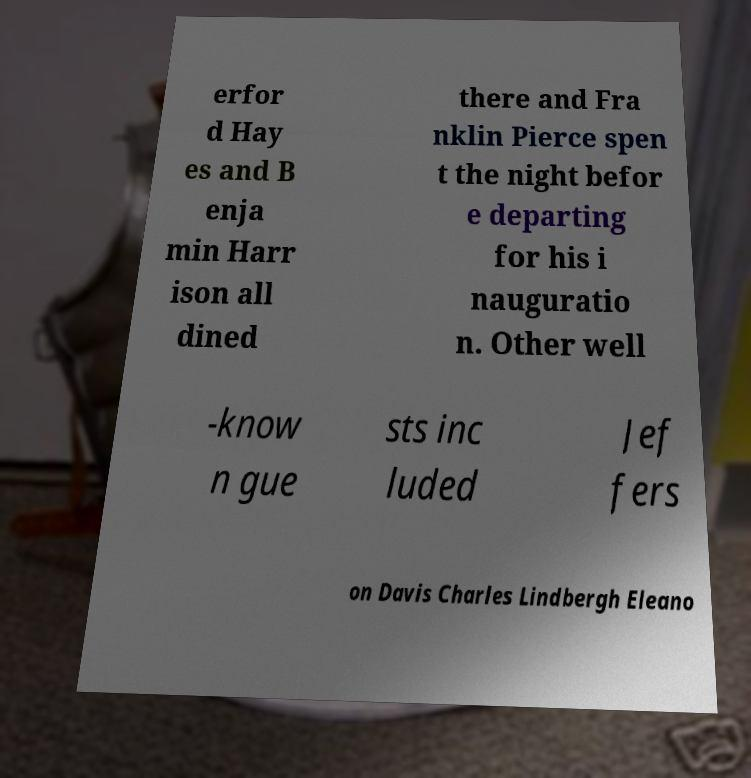For documentation purposes, I need the text within this image transcribed. Could you provide that? erfor d Hay es and B enja min Harr ison all dined there and Fra nklin Pierce spen t the night befor e departing for his i nauguratio n. Other well -know n gue sts inc luded Jef fers on Davis Charles Lindbergh Eleano 